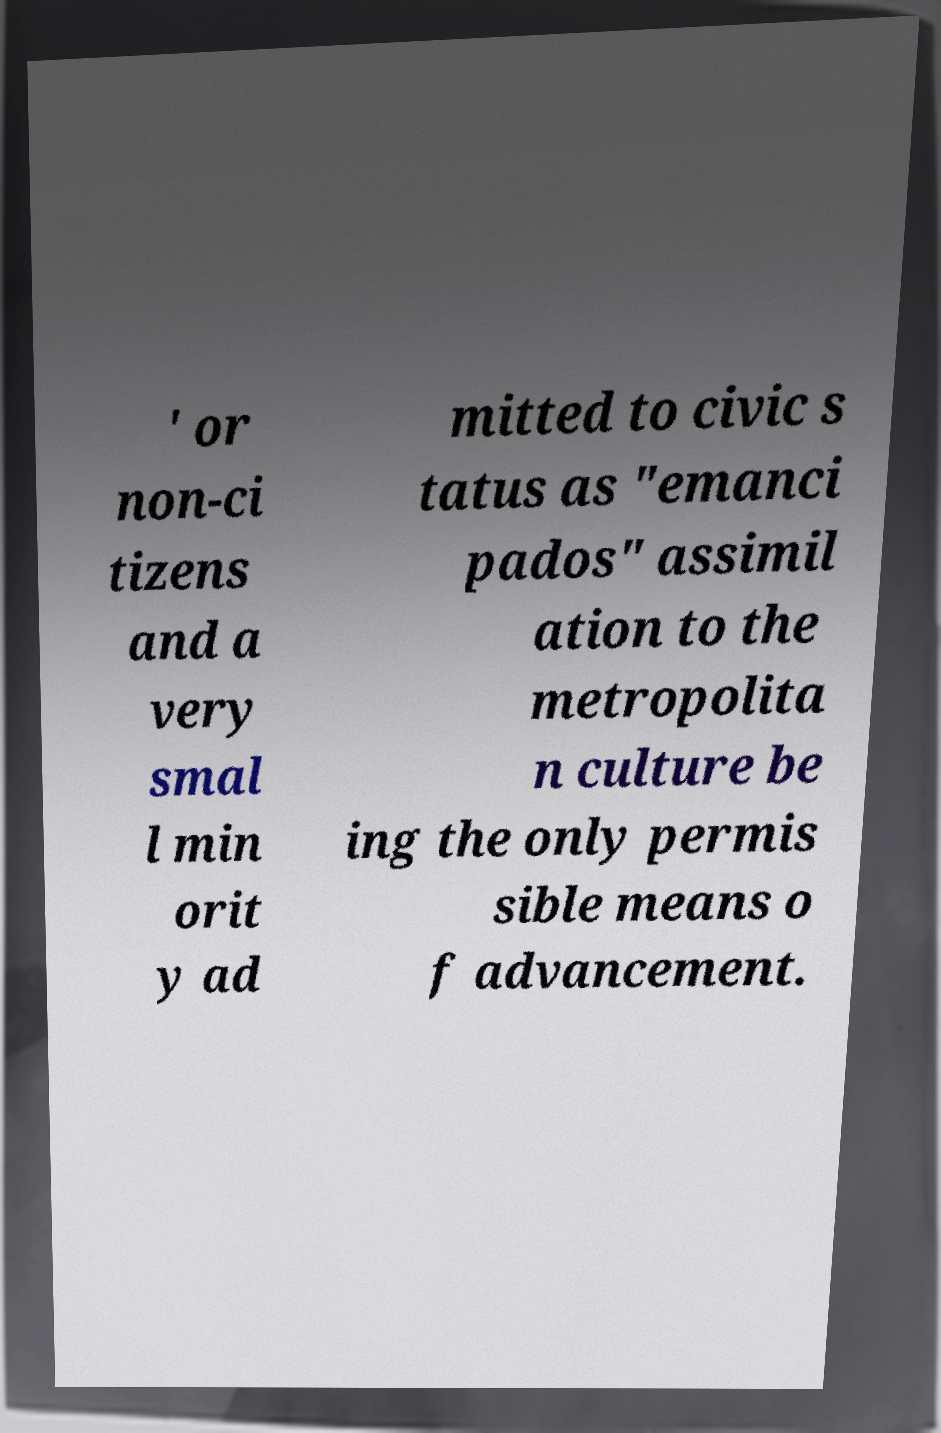Could you assist in decoding the text presented in this image and type it out clearly? ' or non-ci tizens and a very smal l min orit y ad mitted to civic s tatus as "emanci pados" assimil ation to the metropolita n culture be ing the only permis sible means o f advancement. 